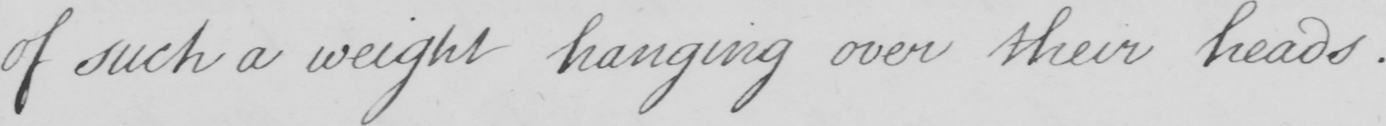What is written in this line of handwriting? of such a weight hanging over their heads . 